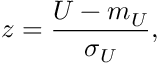Convert formula to latex. <formula><loc_0><loc_0><loc_500><loc_500>z = { \frac { U - m _ { U } } { \sigma _ { U } } } ,</formula> 